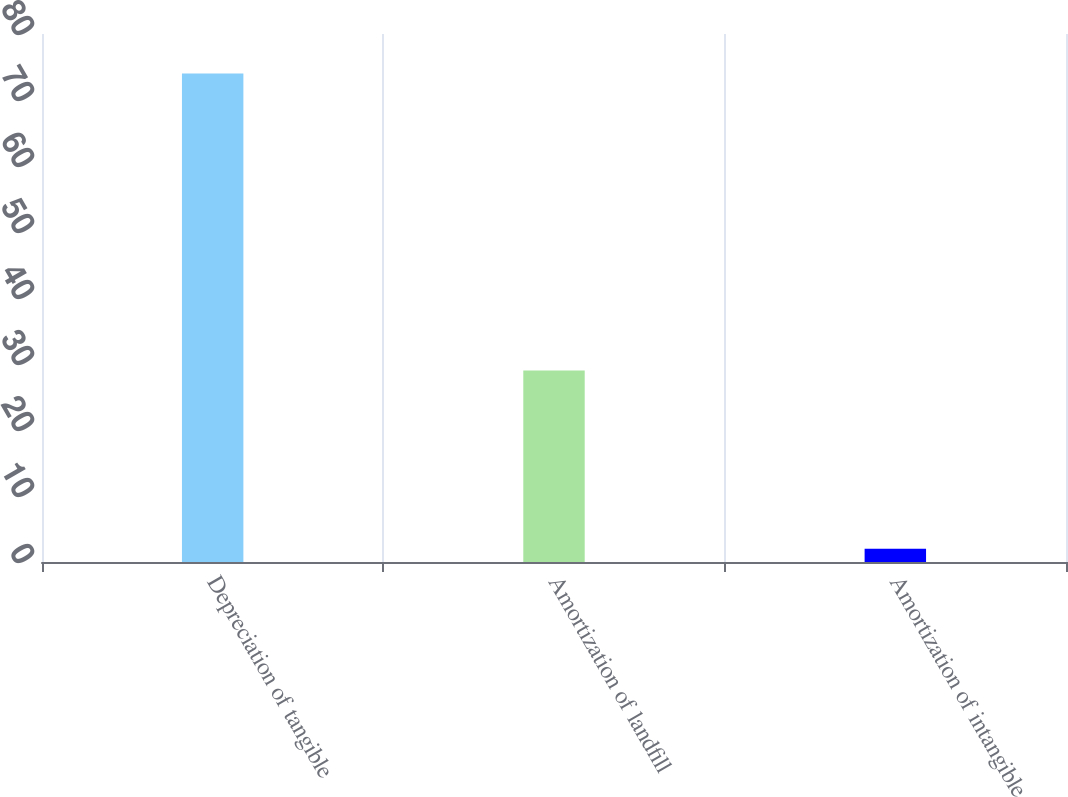<chart> <loc_0><loc_0><loc_500><loc_500><bar_chart><fcel>Depreciation of tangible<fcel>Amortization of landfill<fcel>Amortization of intangible<nl><fcel>74<fcel>29<fcel>2<nl></chart> 